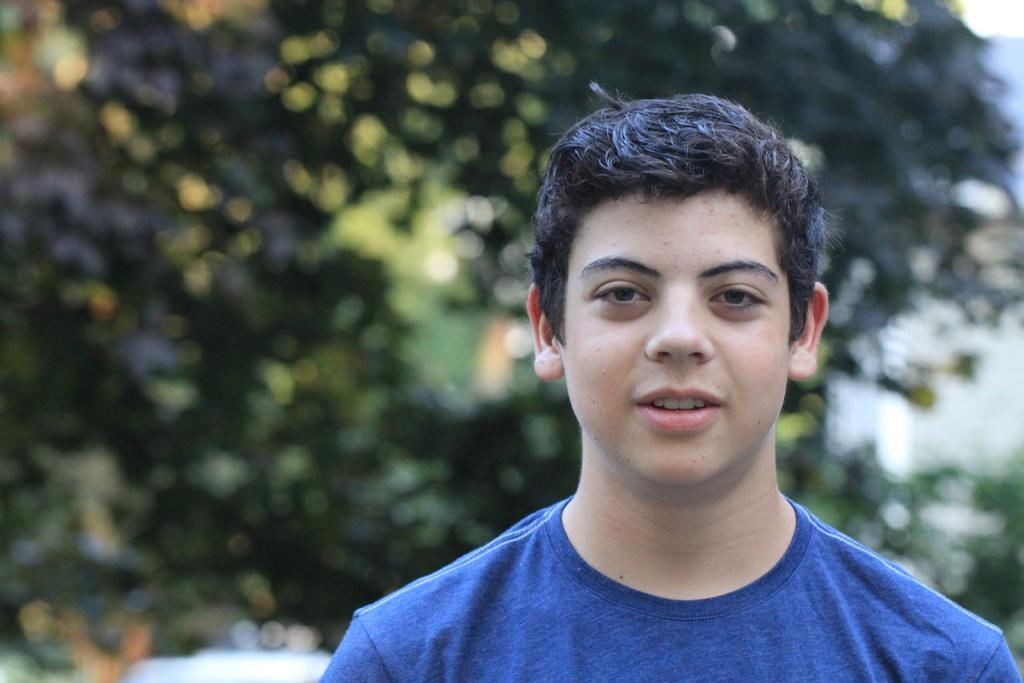What is the main subject in the foreground of the image? There is a kid in the foreground of the image. What can be seen in the background of the image? There is greenery in the background of the image. What type of leather is visible in the image? There is no leather present in the image. What degree of difficulty is the kid attempting in the image? The image does not depict any activity that could be associated with a degree of difficulty. 